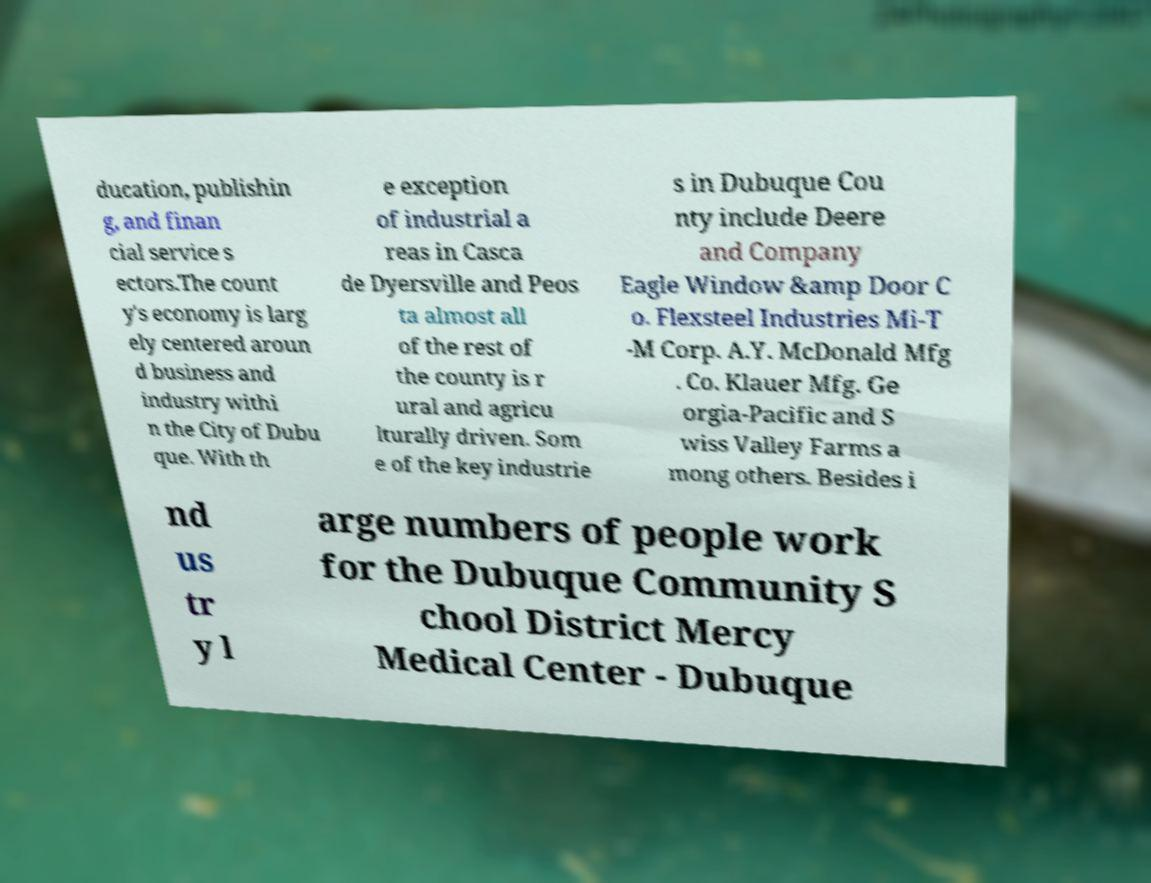For documentation purposes, I need the text within this image transcribed. Could you provide that? ducation, publishin g, and finan cial service s ectors.The count y's economy is larg ely centered aroun d business and industry withi n the City of Dubu que. With th e exception of industrial a reas in Casca de Dyersville and Peos ta almost all of the rest of the county is r ural and agricu lturally driven. Som e of the key industrie s in Dubuque Cou nty include Deere and Company Eagle Window &amp Door C o. Flexsteel Industries Mi-T -M Corp. A.Y. McDonald Mfg . Co. Klauer Mfg. Ge orgia-Pacific and S wiss Valley Farms a mong others. Besides i nd us tr y l arge numbers of people work for the Dubuque Community S chool District Mercy Medical Center - Dubuque 